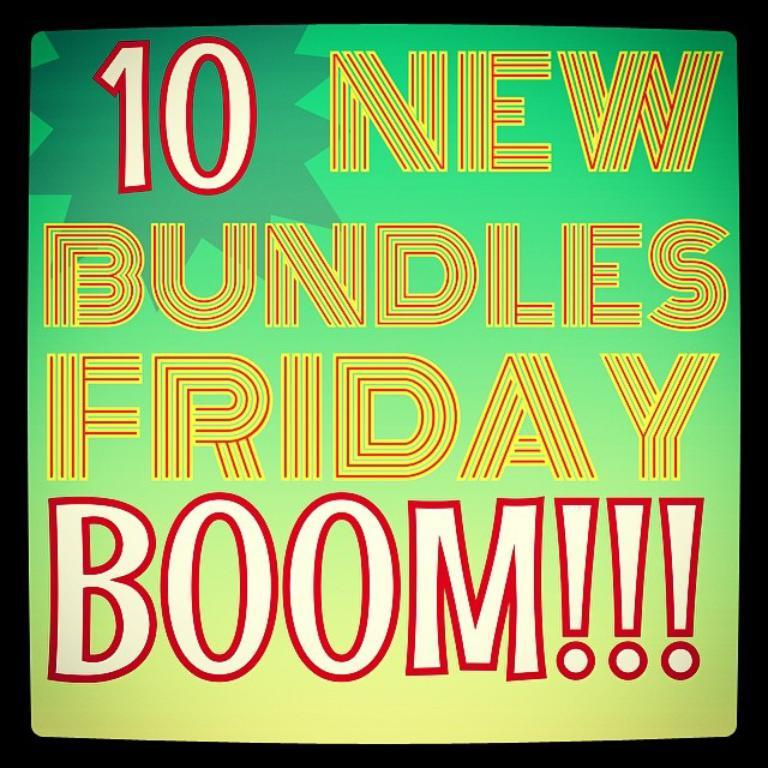What is present in the image that contains information or a message? There is a poster in the image that contains text. Can you describe the content of the poster? The poster contains text, but the specific message or information cannot be determined from the provided facts. What type of flesh can be seen hanging from the poster in the image? There is no flesh present in the image, and the poster contains text, not images of any kind. 